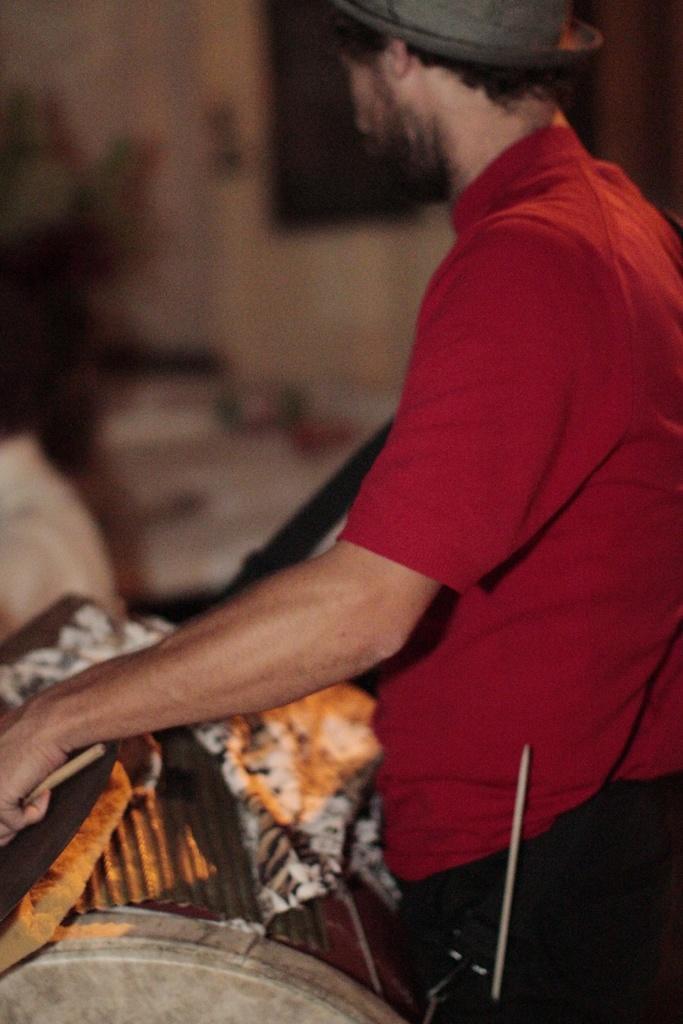Describe this image in one or two sentences. In the image we can see a man standing, wearing clothes, hat and holding drum sticks in hand. Here we can see musical instrument and the background is blurred. 